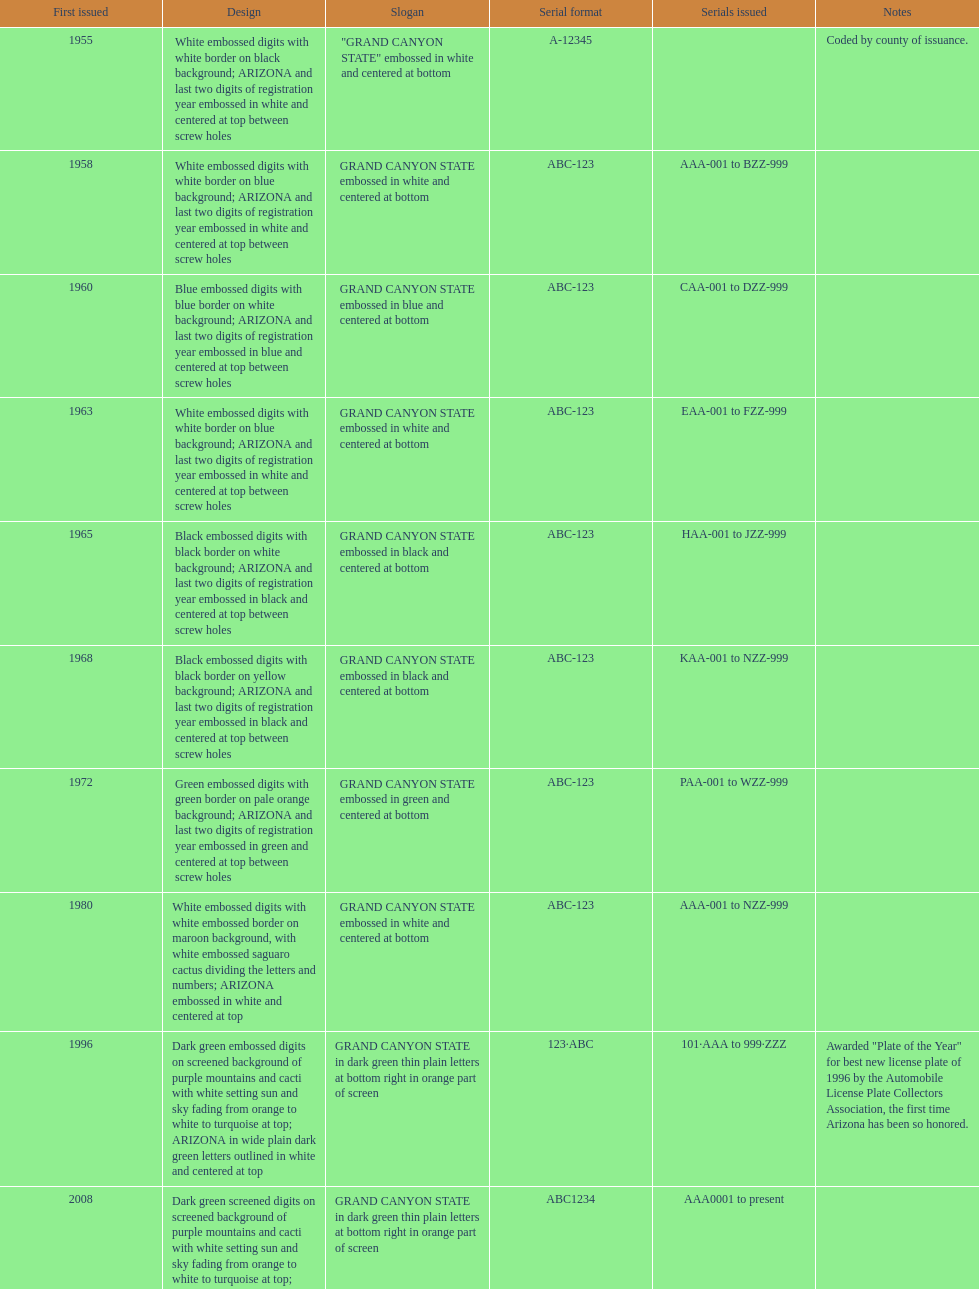What was year was the first arizona license plate made? 1955. 